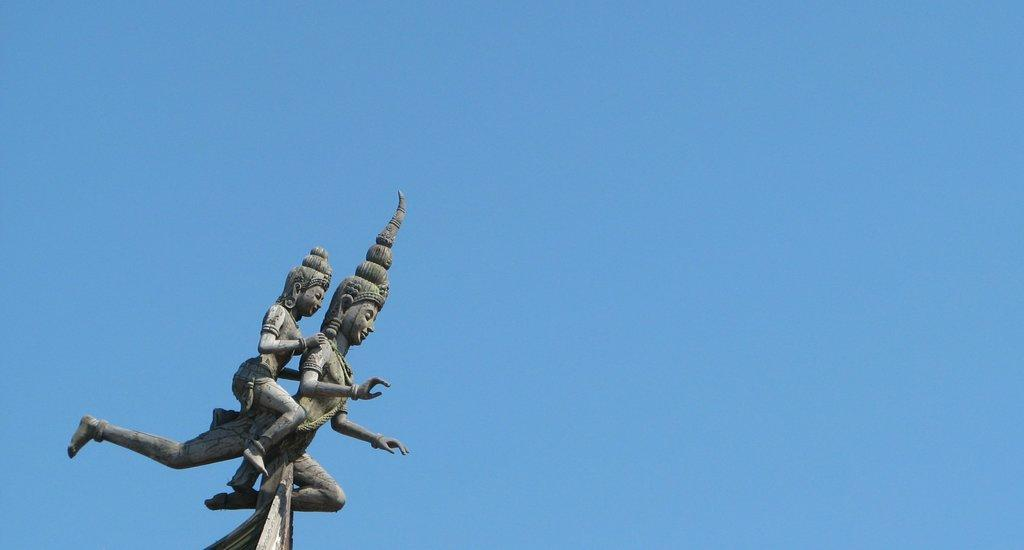How many sculptures can be seen in the image? There are two sculptures in the image. What can be seen in the background of the image? There is sky visible in the background of the image. Are there any bells attached to the sculptures in the image? There is no information about bells or any other specific details about the sculptures in the image. Is there a slave depicted in the image? There is no mention of a slave or any human figures in the image. Is there a secretary present in the image? There is no mention of a secretary or any office-related objects in the image. 